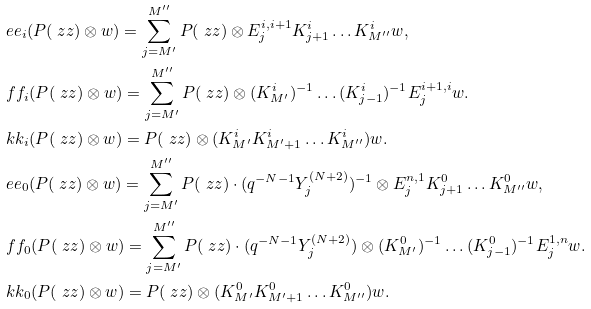<formula> <loc_0><loc_0><loc_500><loc_500>& \ e e _ { i } ( P ( \ z z ) \otimes w ) = \sum _ { j = M ^ { \prime } } ^ { M ^ { \prime \prime } } P ( \ z z ) \otimes E _ { j } ^ { i , i + 1 } K _ { j + 1 } ^ { i } \dots K _ { M ^ { \prime \prime } } ^ { i } w , \\ & \ f f _ { i } ( P ( \ z z ) \otimes w ) = \sum _ { j = M ^ { \prime } } ^ { M ^ { \prime \prime } } P ( \ z z ) \otimes ( K _ { M ^ { \prime } } ^ { i } ) ^ { - 1 } \dots ( K _ { j - 1 } ^ { i } ) ^ { - 1 } E _ { j } ^ { i + 1 , i } w . \\ & \ k k _ { i } ( P ( \ z z ) \otimes w ) = P ( \ z z ) \otimes ( K ^ { i } _ { M ^ { \prime } } K ^ { i } _ { M ^ { \prime } + 1 } \dots K ^ { i } _ { M ^ { \prime \prime } } ) w . \\ & \ e e _ { 0 } ( P ( \ z z ) \otimes w ) = \sum _ { j = M ^ { \prime } } ^ { M ^ { \prime \prime } } P ( \ z z ) \cdot ( q ^ { - N - 1 } Y _ { j } ^ { ( N + 2 ) } ) ^ { - 1 } \otimes E _ { j } ^ { n , 1 } K _ { j + 1 } ^ { 0 } \dots K _ { M ^ { \prime \prime } } ^ { 0 } w , \\ & \ f f _ { 0 } ( P ( \ z z ) \otimes w ) = \sum _ { j = M ^ { \prime } } ^ { M ^ { \prime \prime } } P ( \ z z ) \cdot ( q ^ { - N - 1 } Y _ { j } ^ { ( N + 2 ) } ) \otimes ( K _ { M ^ { \prime } } ^ { 0 } ) ^ { - 1 } \dots ( K _ { j - 1 } ^ { 0 } ) ^ { - 1 } E _ { j } ^ { 1 , n } w . \\ & \ k k _ { 0 } ( P ( \ z z ) \otimes w ) = P ( \ z z ) \otimes ( K ^ { 0 } _ { M ^ { \prime } } K ^ { 0 } _ { M ^ { \prime } + 1 } \dots K ^ { 0 } _ { M ^ { \prime \prime } } ) w .</formula> 